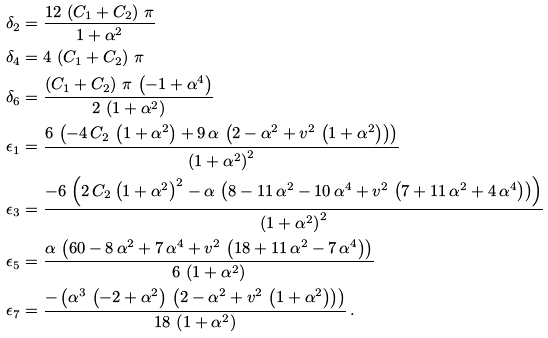<formula> <loc_0><loc_0><loc_500><loc_500>\delta _ { 2 } & = \frac { 1 2 \, \left ( C _ { 1 } + C _ { 2 } \right ) \, \pi } { 1 + { \alpha } ^ { 2 } } \\ \delta _ { 4 } & = 4 \, \left ( C _ { 1 } + C _ { 2 } \right ) \, \pi \\ \delta _ { 6 } & = \frac { \left ( C _ { 1 } + C _ { 2 } \right ) \, \pi \, \left ( - 1 + { \alpha } ^ { 4 } \right ) } { 2 \, \left ( 1 + { \alpha } ^ { 2 } \right ) } \\ \epsilon _ { 1 } & = \frac { 6 \, \left ( - 4 \, C _ { 2 } \, \left ( 1 + { \alpha } ^ { 2 } \right ) + 9 \, \alpha \, \left ( 2 - { \alpha } ^ { 2 } + v ^ { 2 } \, \left ( 1 + { \alpha } ^ { 2 } \right ) \right ) \right ) } { { \left ( 1 + { \alpha } ^ { 2 } \right ) } ^ { 2 } } \\ \epsilon _ { 3 } & = \frac { - 6 \, \left ( 2 \, C _ { 2 } \, { \left ( 1 + { \alpha } ^ { 2 } \right ) } ^ { 2 } - \alpha \, \left ( 8 - 1 1 \, { \alpha } ^ { 2 } - 1 0 \, { \alpha } ^ { 4 } + v ^ { 2 } \, \left ( 7 + 1 1 \, { \alpha } ^ { 2 } + 4 \, { \alpha } ^ { 4 } \right ) \right ) \right ) } { { \left ( 1 + { \alpha } ^ { 2 } \right ) } ^ { 2 } } \\ \epsilon _ { 5 } & = \frac { \alpha \, \left ( 6 0 - 8 \, { \alpha } ^ { 2 } + 7 \, { \alpha } ^ { 4 } + v ^ { 2 } \, \left ( 1 8 + 1 1 \, { \alpha } ^ { 2 } - 7 \, { \alpha } ^ { 4 } \right ) \right ) } { 6 \, \left ( 1 + { \alpha } ^ { 2 } \right ) } \\ \epsilon _ { 7 } & = \frac { - \left ( { \alpha } ^ { 3 } \, \left ( - 2 + { \alpha } ^ { 2 } \right ) \, \left ( 2 - { \alpha } ^ { 2 } + v ^ { 2 } \, \left ( 1 + { \alpha } ^ { 2 } \right ) \right ) \right ) } { 1 8 \, \left ( 1 + { \alpha } ^ { 2 } \right ) } \, .</formula> 